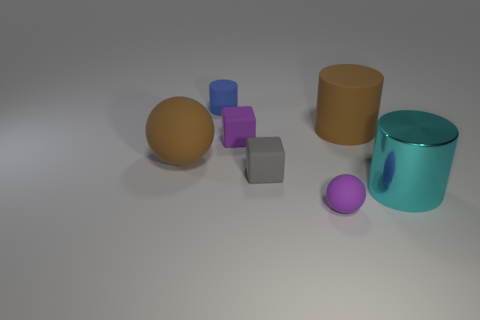What number of cyan matte blocks have the same size as the brown matte cylinder?
Make the answer very short. 0. There is a large matte thing to the left of the big brown cylinder; is it the same color as the matte thing on the right side of the purple ball?
Provide a succinct answer. Yes. There is a big cyan metal cylinder; are there any big objects on the right side of it?
Give a very brief answer. No. What is the color of the small matte object that is both on the right side of the purple block and behind the small rubber sphere?
Provide a succinct answer. Gray. Are there any matte cubes that have the same color as the big sphere?
Your answer should be compact. No. Do the small purple object that is right of the small purple block and the large cylinder that is in front of the large rubber cylinder have the same material?
Give a very brief answer. No. How big is the rubber object in front of the big cyan object?
Your response must be concise. Small. How big is the cyan cylinder?
Provide a short and direct response. Large. There is a brown matte object that is to the left of the cube that is behind the large matte thing that is left of the small gray matte object; what size is it?
Your answer should be compact. Large. Are there any big brown spheres that have the same material as the purple ball?
Your answer should be compact. Yes. 